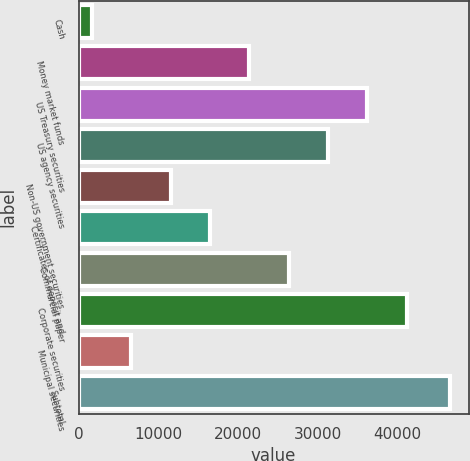<chart> <loc_0><loc_0><loc_500><loc_500><bar_chart><fcel>Cash<fcel>Money market funds<fcel>US Treasury securities<fcel>US agency securities<fcel>Non-US government securities<fcel>Certificates of deposit and<fcel>Commercial paper<fcel>Corporate securities<fcel>Municipal securities<fcel>Subtotal<nl><fcel>1690<fcel>21418.4<fcel>36214.7<fcel>31282.6<fcel>11554.2<fcel>16486.3<fcel>26350.5<fcel>41146.8<fcel>6622.1<fcel>46568<nl></chart> 